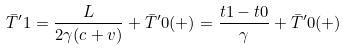Convert formula to latex. <formula><loc_0><loc_0><loc_500><loc_500>\bar { T } ^ { \prime } 1 = \frac { L } { 2 \gamma ( c + v ) } + \bar { T } ^ { \prime } 0 ( + ) = \frac { t 1 - t 0 } { \gamma } + \bar { T } ^ { \prime } 0 ( + )</formula> 